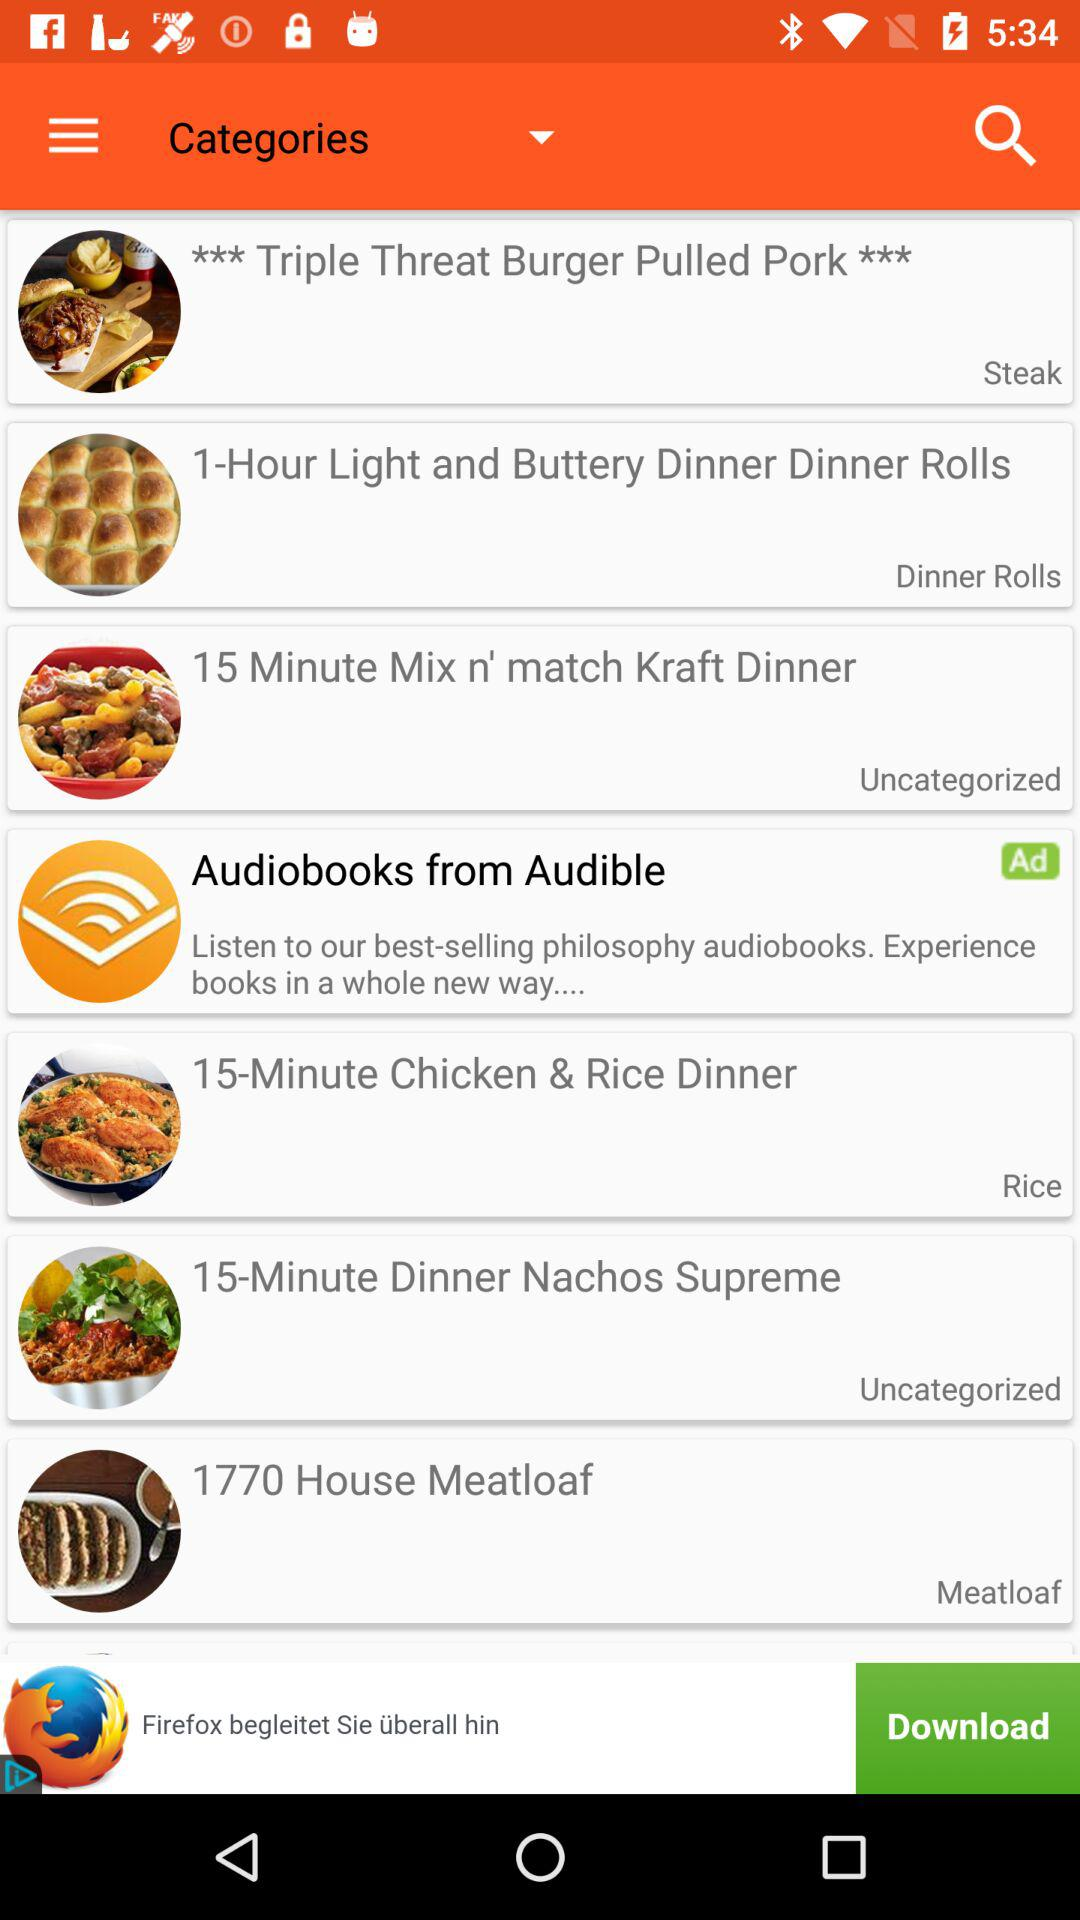How many receipts are uncategorized?
When the provided information is insufficient, respond with <no answer>. <no answer> 